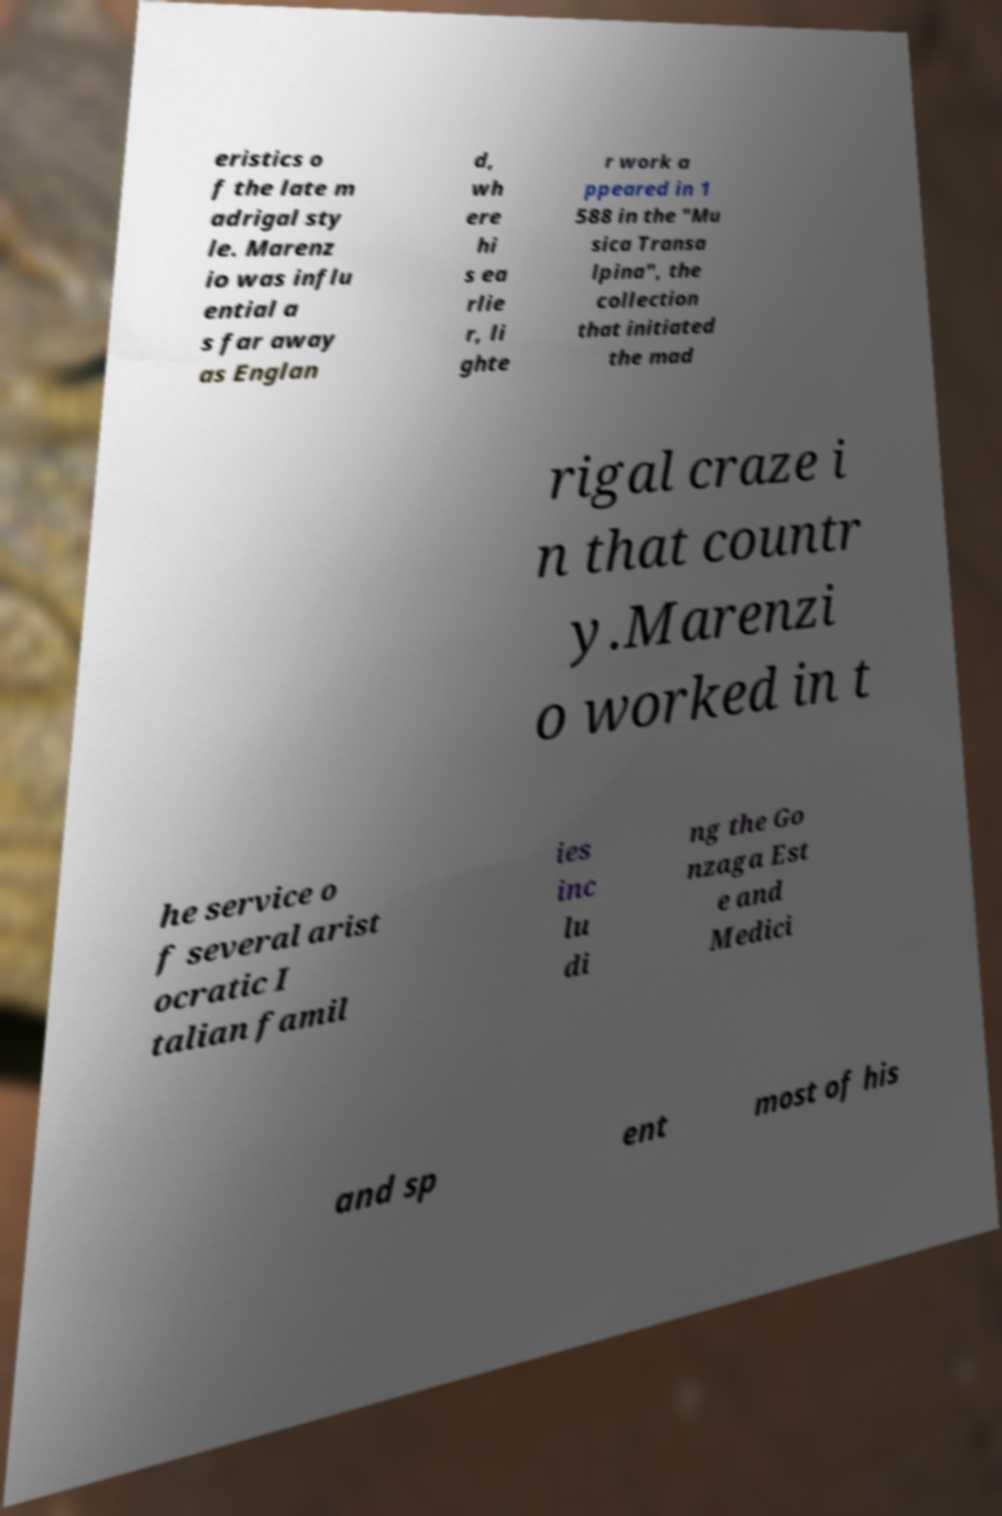What messages or text are displayed in this image? I need them in a readable, typed format. eristics o f the late m adrigal sty le. Marenz io was influ ential a s far away as Englan d, wh ere hi s ea rlie r, li ghte r work a ppeared in 1 588 in the "Mu sica Transa lpina", the collection that initiated the mad rigal craze i n that countr y.Marenzi o worked in t he service o f several arist ocratic I talian famil ies inc lu di ng the Go nzaga Est e and Medici and sp ent most of his 